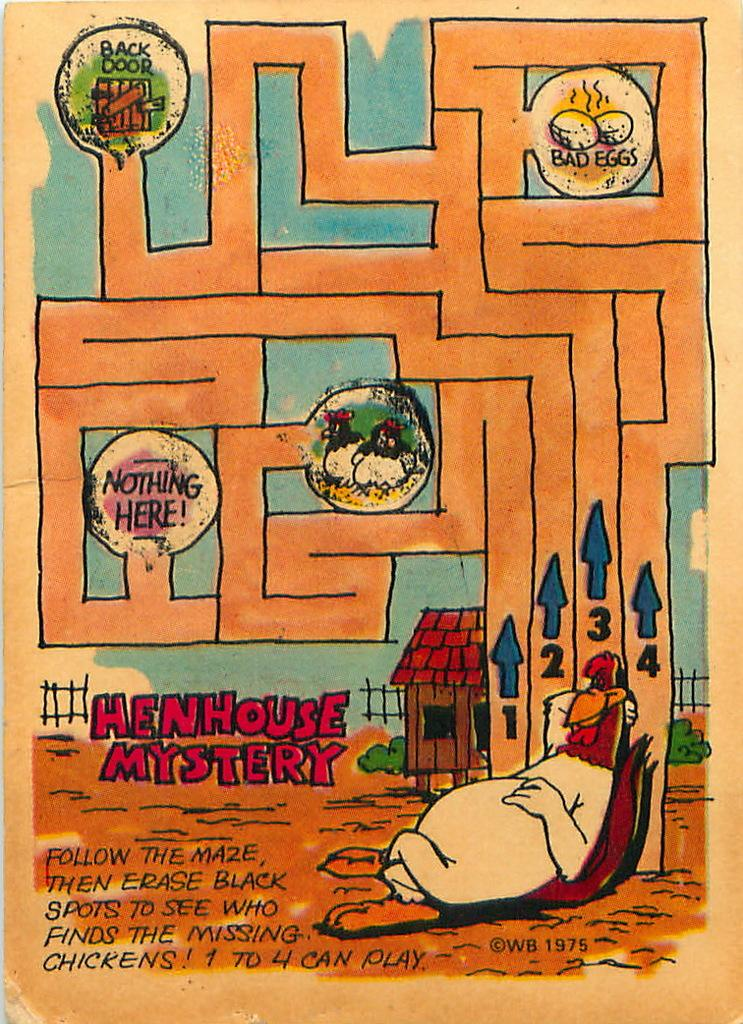<image>
Present a compact description of the photo's key features. A maze titled Henhouse Mystery that looks hand drawn. 